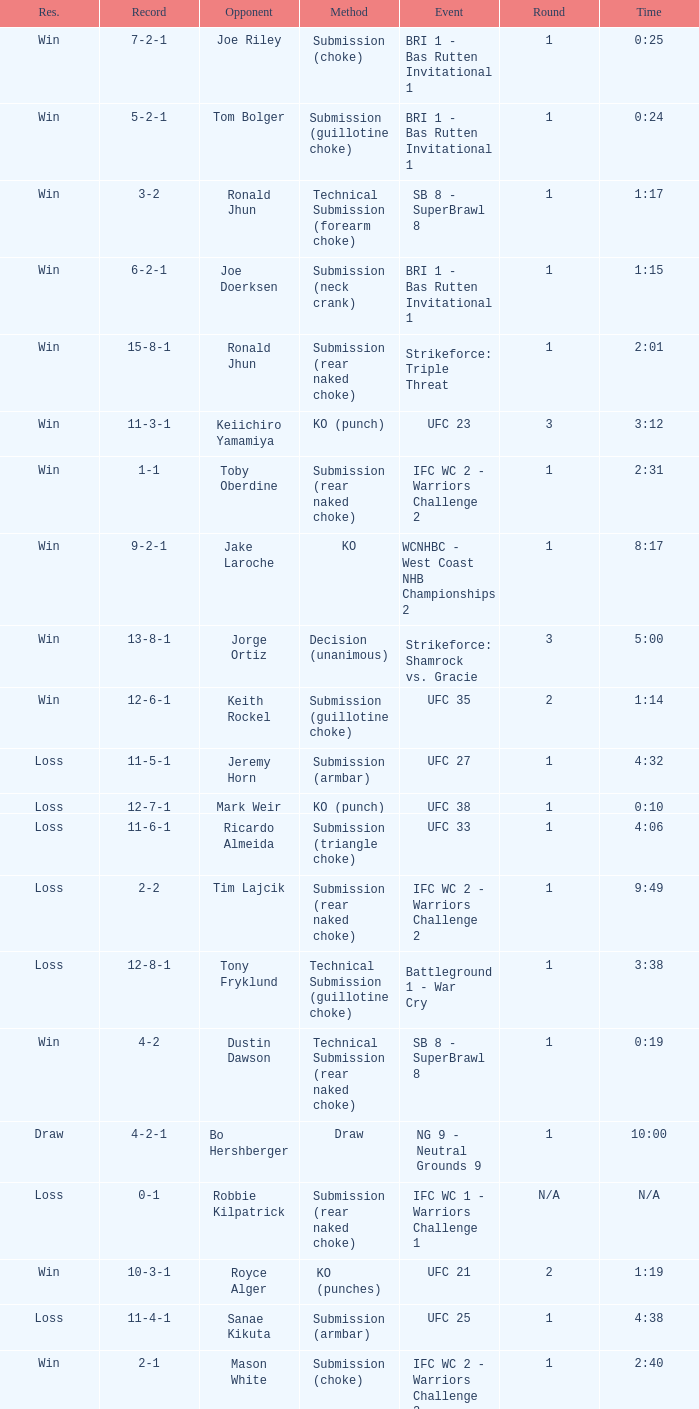Who was the opponent when the fight had a time of 2:01? Ronald Jhun. 